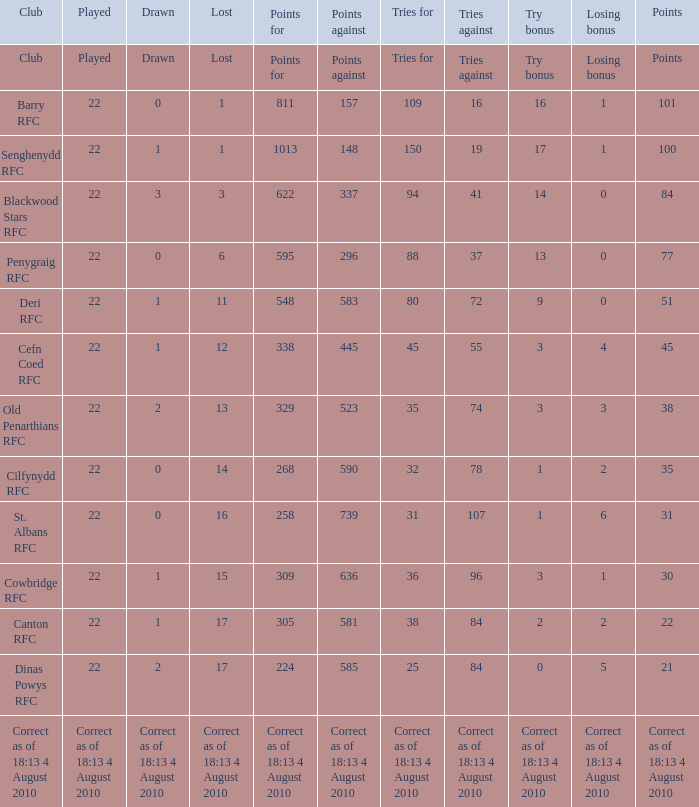What is the lost when the club was Barry RFC? 1.0. 